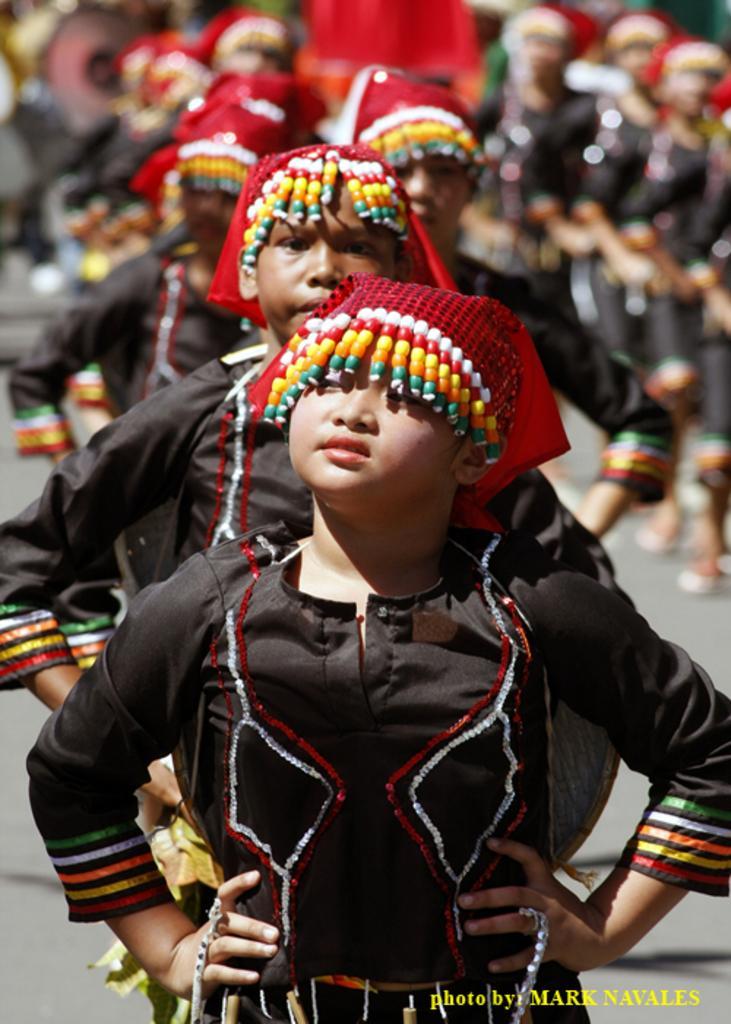In one or two sentences, can you explain what this image depicts? In the picture there is a road, on the road there are many children standing, they are wearing a different costume. 